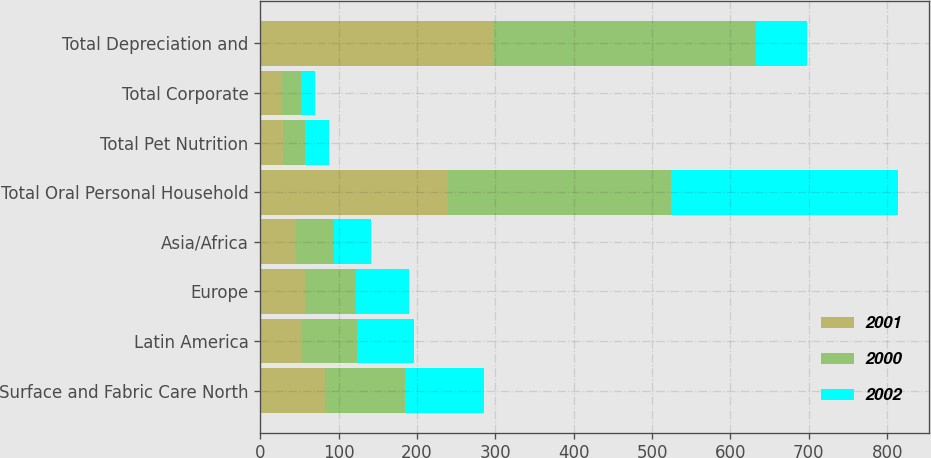Convert chart to OTSL. <chart><loc_0><loc_0><loc_500><loc_500><stacked_bar_chart><ecel><fcel>Surface and Fabric Care North<fcel>Latin America<fcel>Europe<fcel>Asia/Africa<fcel>Total Oral Personal Household<fcel>Total Pet Nutrition<fcel>Total Corporate<fcel>Total Depreciation and<nl><fcel>2001<fcel>82.1<fcel>53.8<fcel>57.3<fcel>46.3<fcel>239.5<fcel>28.7<fcel>28.3<fcel>296.5<nl><fcel>2000<fcel>102.8<fcel>69.3<fcel>64.9<fcel>47.8<fcel>284.8<fcel>28.1<fcel>23.3<fcel>336.2<nl><fcel>2002<fcel>101.2<fcel>73<fcel>67.8<fcel>47<fcel>289<fcel>30.6<fcel>18.2<fcel>64.9<nl></chart> 